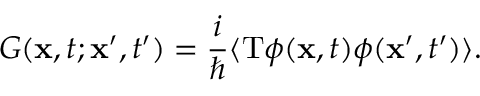<formula> <loc_0><loc_0><loc_500><loc_500>G ( { x } , t ; { x ^ { \prime } } , t ^ { \prime } ) = { \frac { i } { } } \langle T \phi ( { x } , t ) \phi ( { x ^ { \prime } } , t ^ { \prime } ) \rangle .</formula> 